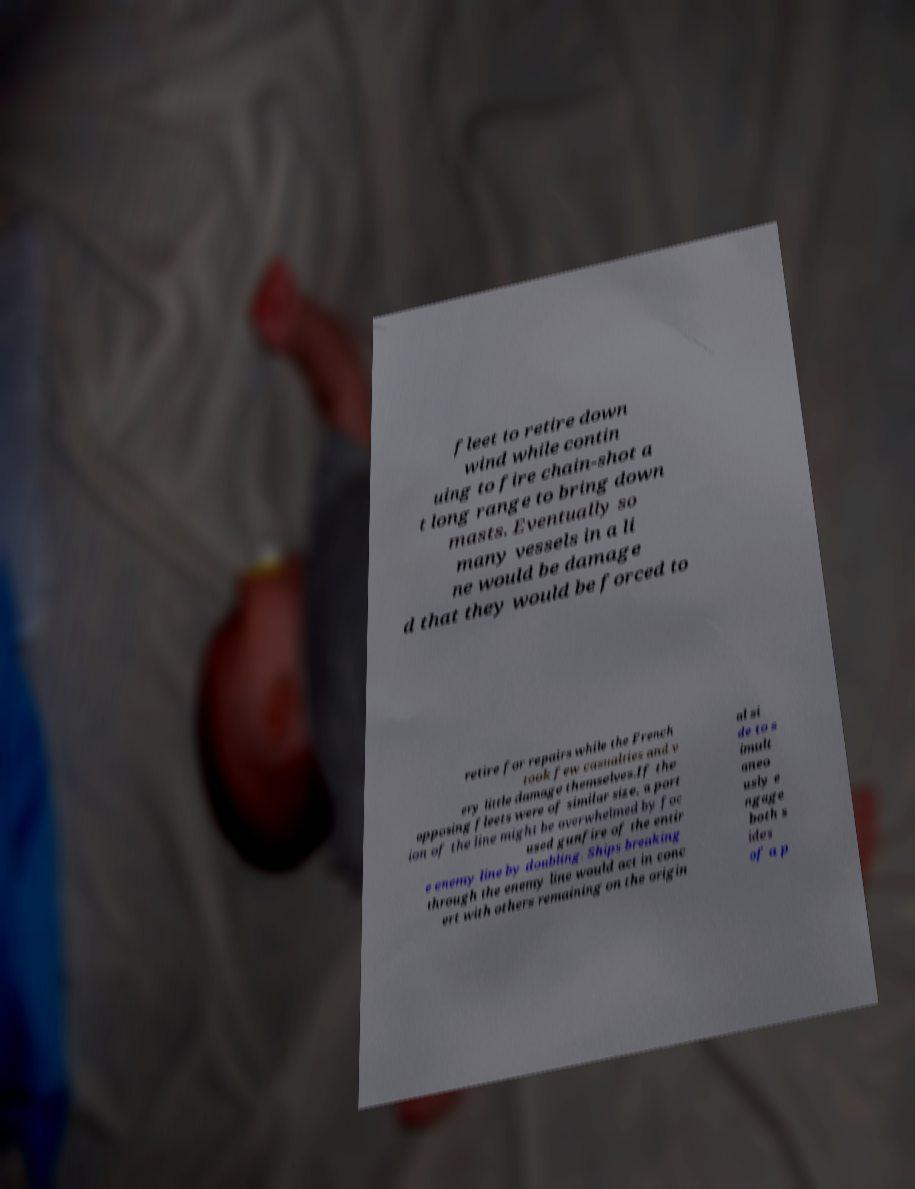There's text embedded in this image that I need extracted. Can you transcribe it verbatim? fleet to retire down wind while contin uing to fire chain-shot a t long range to bring down masts. Eventually so many vessels in a li ne would be damage d that they would be forced to retire for repairs while the French took few casualties and v ery little damage themselves.If the opposing fleets were of similar size, a port ion of the line might be overwhelmed by foc used gunfire of the entir e enemy line by doubling. Ships breaking through the enemy line would act in conc ert with others remaining on the origin al si de to s imult aneo usly e ngage both s ides of a p 